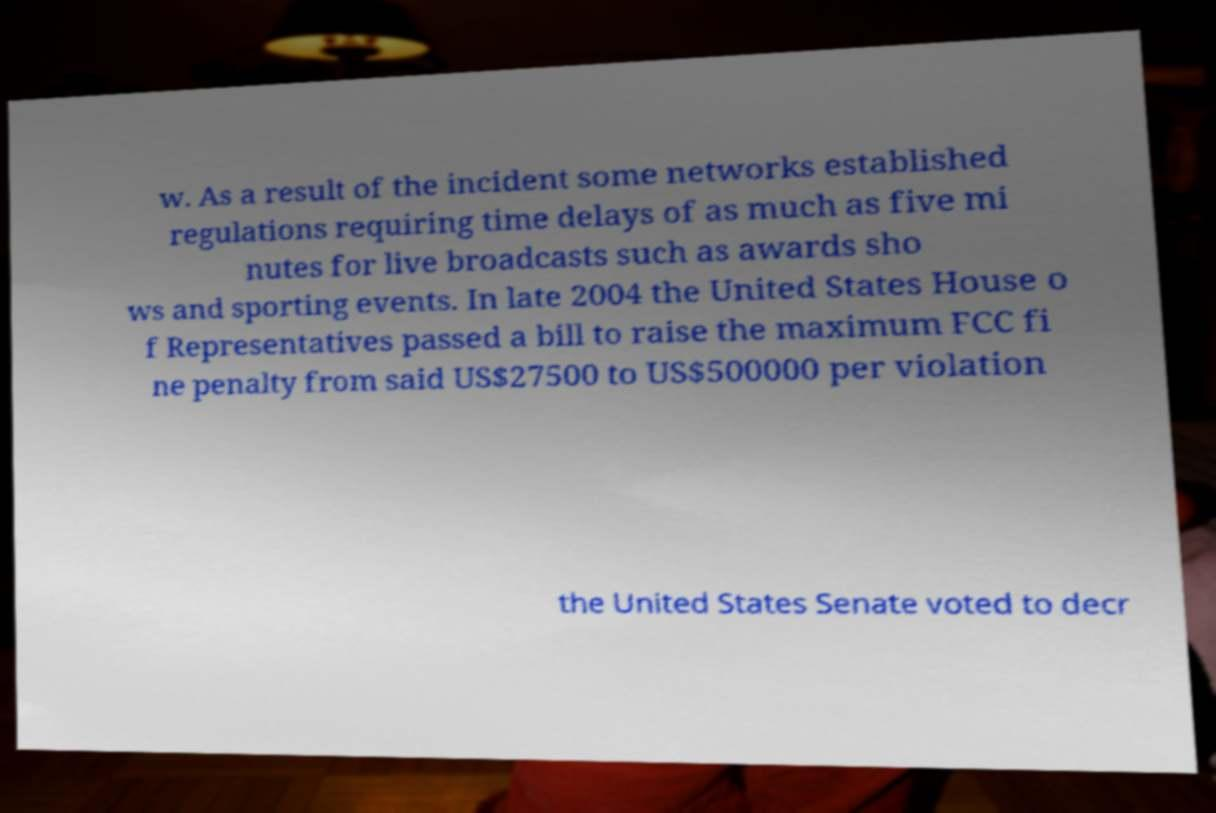Could you extract and type out the text from this image? w. As a result of the incident some networks established regulations requiring time delays of as much as five mi nutes for live broadcasts such as awards sho ws and sporting events. In late 2004 the United States House o f Representatives passed a bill to raise the maximum FCC fi ne penalty from said US$27500 to US$500000 per violation the United States Senate voted to decr 